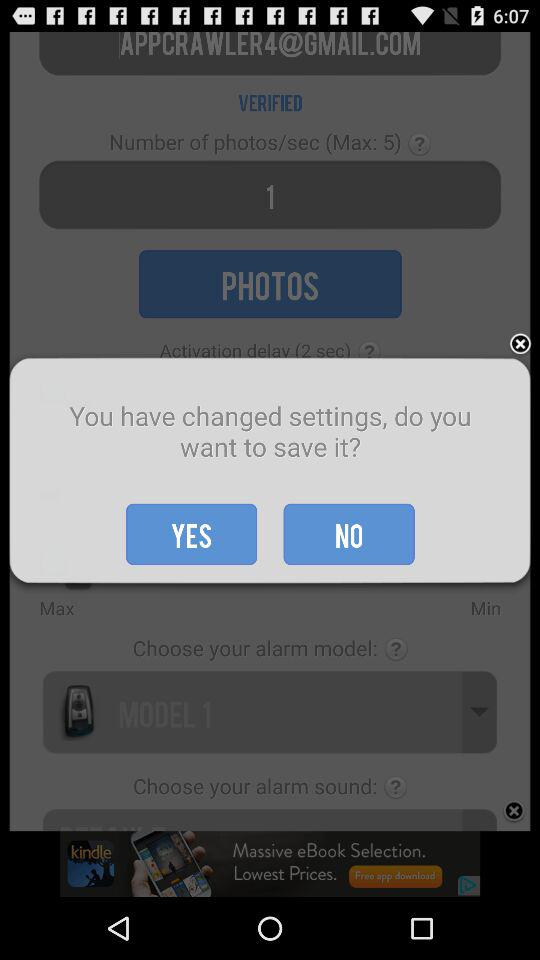What is the email address of the user? The email address is APPCRAWLER4@GMAIL.COM. 